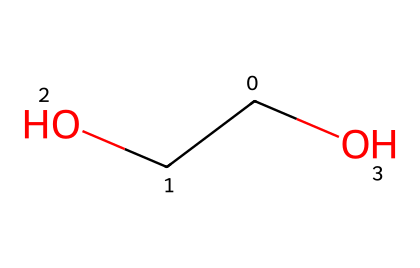What is the name of this chemical? The structure corresponds to polyethylene oxide due to its repeating units of ethylene oxide in the backbone and the presence of the ether functional group. The representation shows a polymer with a long carbon chain.
Answer: polyethylene oxide How many carbon atoms are present? By analyzing the SMILES representation, "C(CO)O," there is one main carbon atom connected to another carbon atom (in the CO group), resulting in a total of two carbon atoms.
Answer: two What type of bonding is present in the backbone of this chemical? The backbone consists of carbon-carbon and carbon-oxygen single bonds, characteristic of the ether functional group found in polyethylene oxide.
Answer: single bonds Does this chemical exhibit non-Newtonian behavior? Yes, polyethylene oxide is known for its non-Newtonian fluid characteristics due to its ability to change viscosity under stress, behaving as a shear-thinning fluid.
Answer: yes Which functional group is present in the chemical structure? The structure shows an ether functional group (R-O-R') where the oxygen is bonded to two carbon atoms, typical of polyethylene oxide.
Answer: ether What is the primary application of polyethylene oxide? Polyethylene oxide is primarily used in bulletproof vests and other applications requiring non-Newtonian fluid behavior due to its capacity to absorb and dissipate energy.
Answer: bulletproof vests What happens to the viscosity of this fluid under shear stress? Under shear stress, the viscosity of polyethylene oxide decreases, exhibiting shear-thinning behavior, an essential characteristic of non-Newtonian fluids.
Answer: decreases 